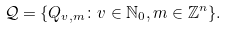Convert formula to latex. <formula><loc_0><loc_0><loc_500><loc_500>\mathcal { Q } = \{ Q _ { v , m } \colon v \in \mathbb { N } _ { 0 } , m \in \mathbb { Z } ^ { n } \} .</formula> 